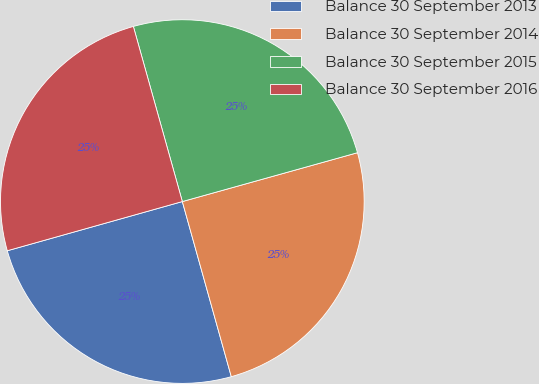Convert chart to OTSL. <chart><loc_0><loc_0><loc_500><loc_500><pie_chart><fcel>Balance 30 September 2013<fcel>Balance 30 September 2014<fcel>Balance 30 September 2015<fcel>Balance 30 September 2016<nl><fcel>24.98%<fcel>24.99%<fcel>25.01%<fcel>25.02%<nl></chart> 